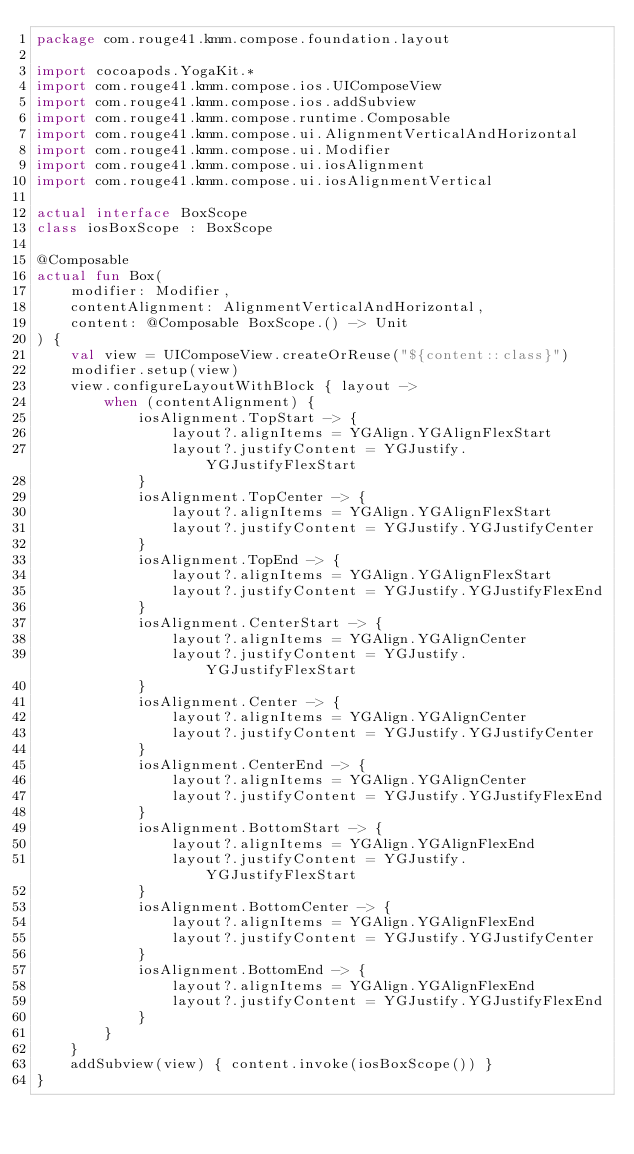<code> <loc_0><loc_0><loc_500><loc_500><_Kotlin_>package com.rouge41.kmm.compose.foundation.layout

import cocoapods.YogaKit.*
import com.rouge41.kmm.compose.ios.UIComposeView
import com.rouge41.kmm.compose.ios.addSubview
import com.rouge41.kmm.compose.runtime.Composable
import com.rouge41.kmm.compose.ui.AlignmentVerticalAndHorizontal
import com.rouge41.kmm.compose.ui.Modifier
import com.rouge41.kmm.compose.ui.iosAlignment
import com.rouge41.kmm.compose.ui.iosAlignmentVertical

actual interface BoxScope
class iosBoxScope : BoxScope

@Composable
actual fun Box(
    modifier: Modifier,
    contentAlignment: AlignmentVerticalAndHorizontal,
    content: @Composable BoxScope.() -> Unit
) {
    val view = UIComposeView.createOrReuse("${content::class}")
    modifier.setup(view)
    view.configureLayoutWithBlock { layout ->
        when (contentAlignment) {
            iosAlignment.TopStart -> {
                layout?.alignItems = YGAlign.YGAlignFlexStart
                layout?.justifyContent = YGJustify.YGJustifyFlexStart
            }
            iosAlignment.TopCenter -> {
                layout?.alignItems = YGAlign.YGAlignFlexStart
                layout?.justifyContent = YGJustify.YGJustifyCenter
            }
            iosAlignment.TopEnd -> {
                layout?.alignItems = YGAlign.YGAlignFlexStart
                layout?.justifyContent = YGJustify.YGJustifyFlexEnd
            }
            iosAlignment.CenterStart -> {
                layout?.alignItems = YGAlign.YGAlignCenter
                layout?.justifyContent = YGJustify.YGJustifyFlexStart
            }
            iosAlignment.Center -> {
                layout?.alignItems = YGAlign.YGAlignCenter
                layout?.justifyContent = YGJustify.YGJustifyCenter
            }
            iosAlignment.CenterEnd -> {
                layout?.alignItems = YGAlign.YGAlignCenter
                layout?.justifyContent = YGJustify.YGJustifyFlexEnd
            }
            iosAlignment.BottomStart -> {
                layout?.alignItems = YGAlign.YGAlignFlexEnd
                layout?.justifyContent = YGJustify.YGJustifyFlexStart
            }
            iosAlignment.BottomCenter -> {
                layout?.alignItems = YGAlign.YGAlignFlexEnd
                layout?.justifyContent = YGJustify.YGJustifyCenter
            }
            iosAlignment.BottomEnd -> {
                layout?.alignItems = YGAlign.YGAlignFlexEnd
                layout?.justifyContent = YGJustify.YGJustifyFlexEnd
            }
        }
    }
    addSubview(view) { content.invoke(iosBoxScope()) }
}</code> 